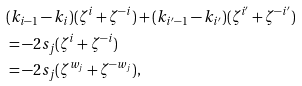<formula> <loc_0><loc_0><loc_500><loc_500>& ( k _ { i - 1 } - k _ { i } ) ( \zeta ^ { i } + \zeta ^ { - i } ) + ( k _ { i ^ { \prime } - 1 } - k _ { i ^ { \prime } } ) ( \zeta ^ { i ^ { \prime } } + \zeta ^ { - i ^ { \prime } } ) \\ & = - 2 s _ { j } ( \zeta ^ { i } + \zeta ^ { - i } ) \\ & = - 2 s _ { j } ( \zeta ^ { w _ { j } } + \zeta ^ { - w _ { j } } ) ,</formula> 